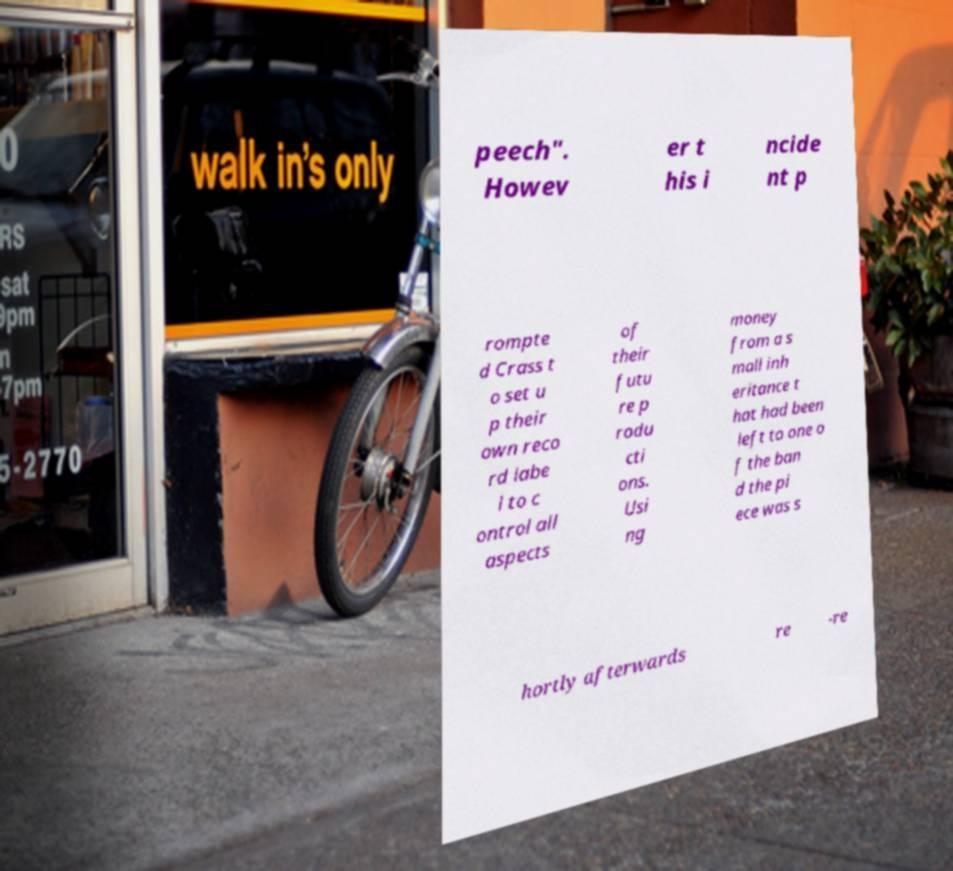There's text embedded in this image that I need extracted. Can you transcribe it verbatim? peech". Howev er t his i ncide nt p rompte d Crass t o set u p their own reco rd labe l to c ontrol all aspects of their futu re p rodu cti ons. Usi ng money from a s mall inh eritance t hat had been left to one o f the ban d the pi ece was s hortly afterwards re -re 